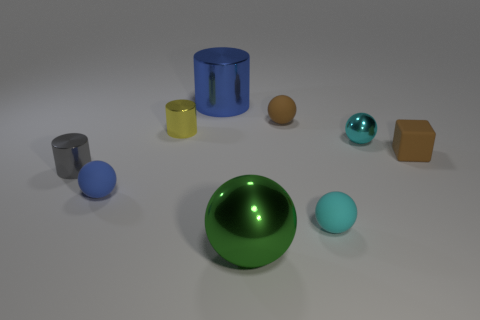Is there anything else that has the same size as the yellow thing?
Make the answer very short. Yes. There is a blue rubber object; what number of tiny metal spheres are behind it?
Provide a short and direct response. 1. Is the number of cyan things that are in front of the gray cylinder the same as the number of tiny metal objects?
Provide a succinct answer. No. What number of objects are either spheres or brown matte things?
Your answer should be very brief. 6. Are there any other things that have the same shape as the yellow metallic thing?
Give a very brief answer. Yes. There is a tiny shiny object that is to the right of the tiny matte ball that is behind the cyan metal object; what is its shape?
Provide a short and direct response. Sphere. The tiny cyan object that is the same material as the large blue object is what shape?
Provide a short and direct response. Sphere. There is a blue object that is right of the matte object that is left of the green metal object; how big is it?
Your response must be concise. Large. The small gray thing has what shape?
Make the answer very short. Cylinder. What number of tiny things are cyan objects or gray metal cylinders?
Ensure brevity in your answer.  3. 